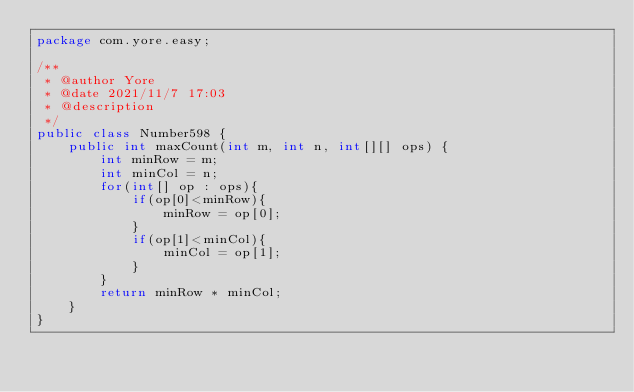<code> <loc_0><loc_0><loc_500><loc_500><_Java_>package com.yore.easy;

/**
 * @author Yore
 * @date 2021/11/7 17:03
 * @description
 */
public class Number598 {
    public int maxCount(int m, int n, int[][] ops) {
        int minRow = m;
        int minCol = n;
        for(int[] op : ops){
            if(op[0]<minRow){
                minRow = op[0];
            }
            if(op[1]<minCol){
                minCol = op[1];
            }
        }
        return minRow * minCol;
    }
}
</code> 